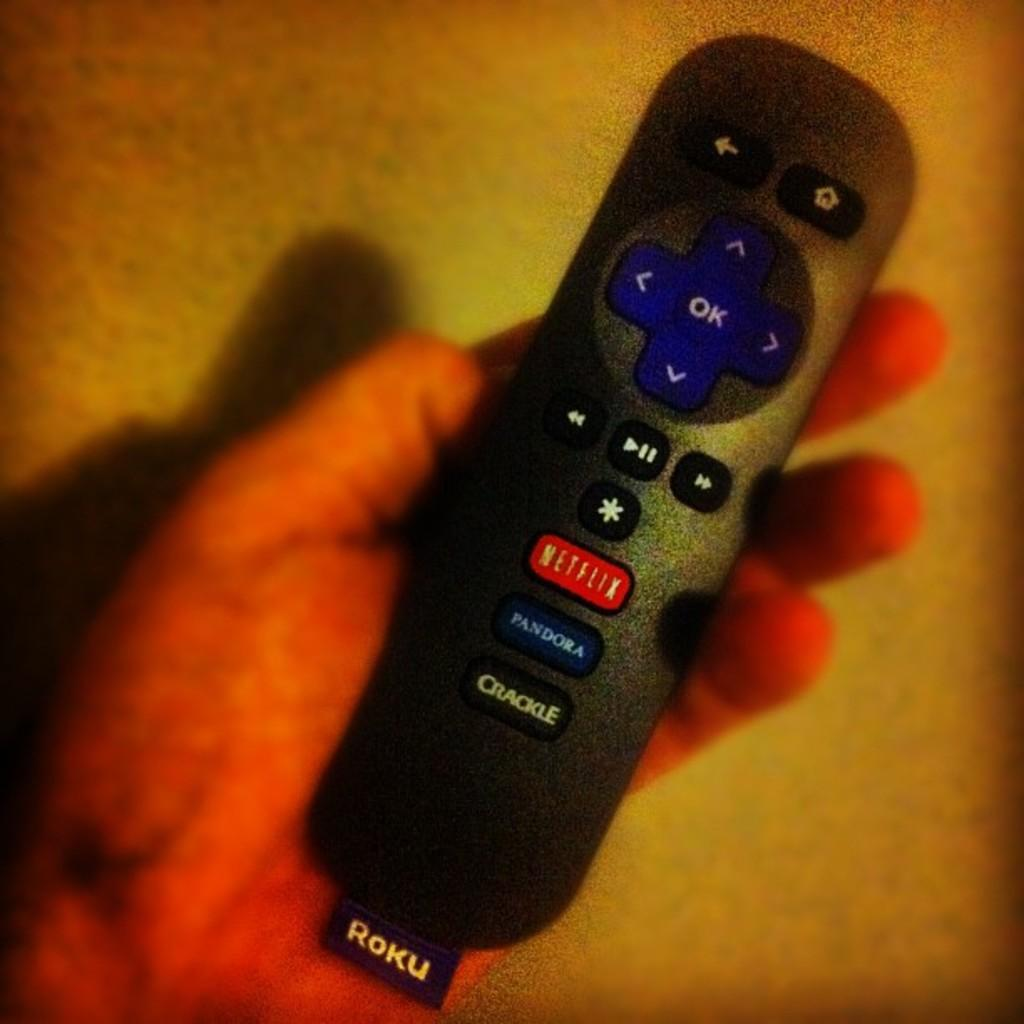<image>
Present a compact description of the photo's key features. A remote that has Netflix and Pandora easy buttons. 